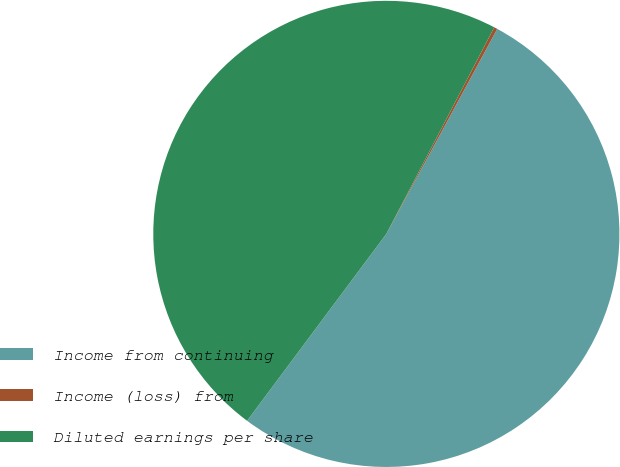<chart> <loc_0><loc_0><loc_500><loc_500><pie_chart><fcel>Income from continuing<fcel>Income (loss) from<fcel>Diluted earnings per share<nl><fcel>52.3%<fcel>0.23%<fcel>47.47%<nl></chart> 